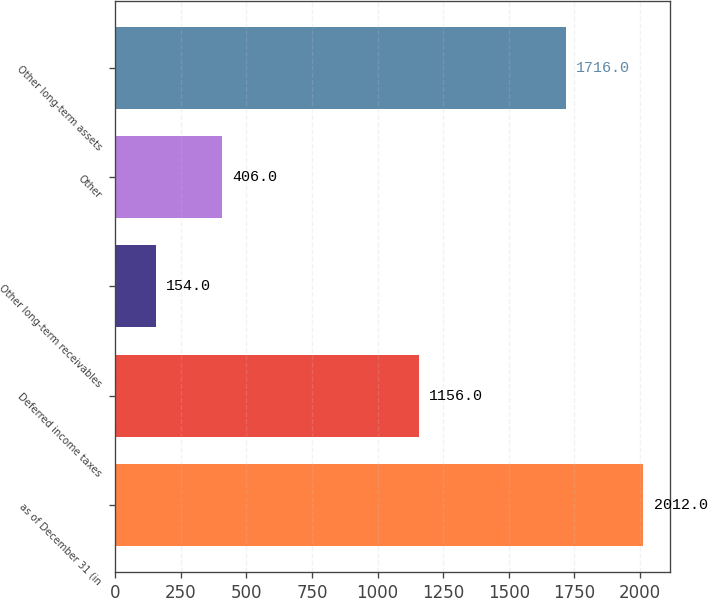Convert chart. <chart><loc_0><loc_0><loc_500><loc_500><bar_chart><fcel>as of December 31 (in<fcel>Deferred income taxes<fcel>Other long-term receivables<fcel>Other<fcel>Other long-term assets<nl><fcel>2012<fcel>1156<fcel>154<fcel>406<fcel>1716<nl></chart> 